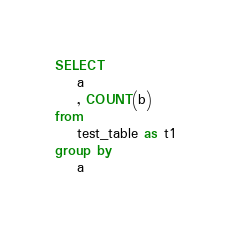<code> <loc_0><loc_0><loc_500><loc_500><_SQL_>SELECT
    a
    , COUNT(b)
from
    test_table as t1
group by
    a
</code> 